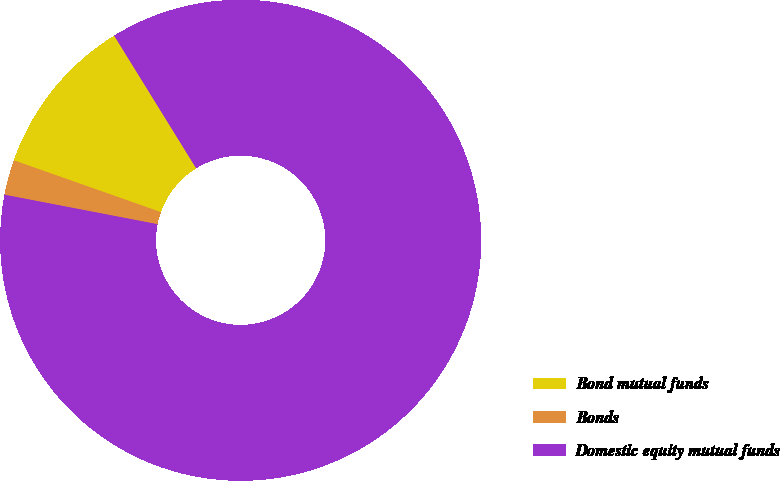Convert chart to OTSL. <chart><loc_0><loc_0><loc_500><loc_500><pie_chart><fcel>Bond mutual funds<fcel>Bonds<fcel>Domestic equity mutual funds<nl><fcel>10.8%<fcel>2.36%<fcel>86.84%<nl></chart> 